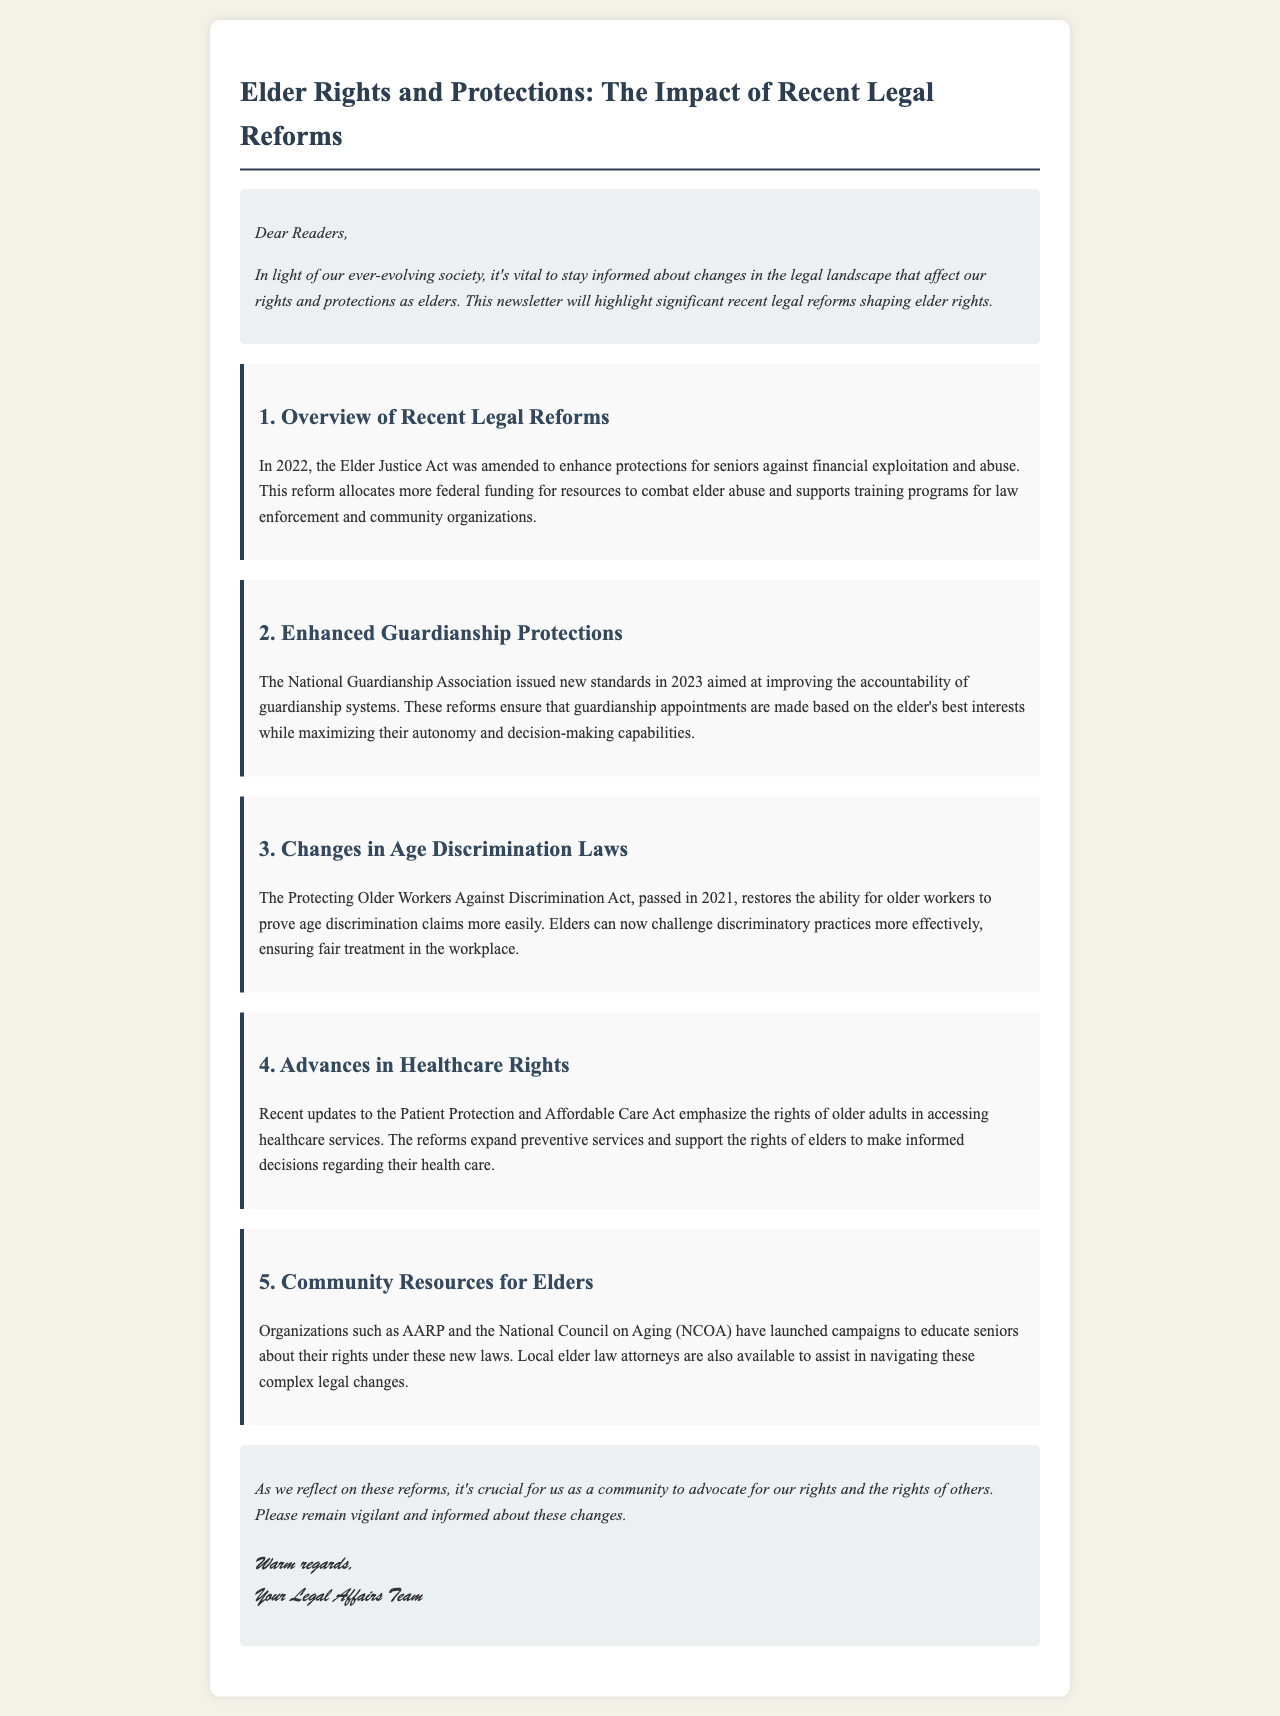What was amended in 2022? The Elder Justice Act was amended to enhance protections for seniors against financial exploitation and abuse.
Answer: Elder Justice Act What organization issued new standards in 2023? The National Guardianship Association issued new standards aimed at improving accountability of guardianship systems.
Answer: National Guardianship Association What year was the Protecting Older Workers Against Discrimination Act passed? The Protecting Older Workers Against Discrimination Act was passed in 2021.
Answer: 2021 What does the recent update to the Patient Protection and Affordable Care Act emphasize? The updates emphasize the rights of older adults in accessing healthcare services.
Answer: Rights of older adults Which organizations launched campaigns to educate seniors about their rights? Organizations such as AARP and the National Council on Aging (NCOA) launched campaigns.
Answer: AARP and NCOA What is crucial for the community according to the closing remarks? It's crucial to advocate for our rights and the rights of others.
Answer: Advocate for rights 